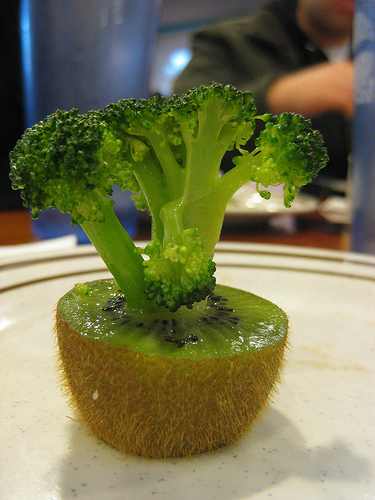<image>
Is there a broccoli on the kiwi? Yes. Looking at the image, I can see the broccoli is positioned on top of the kiwi, with the kiwi providing support. 